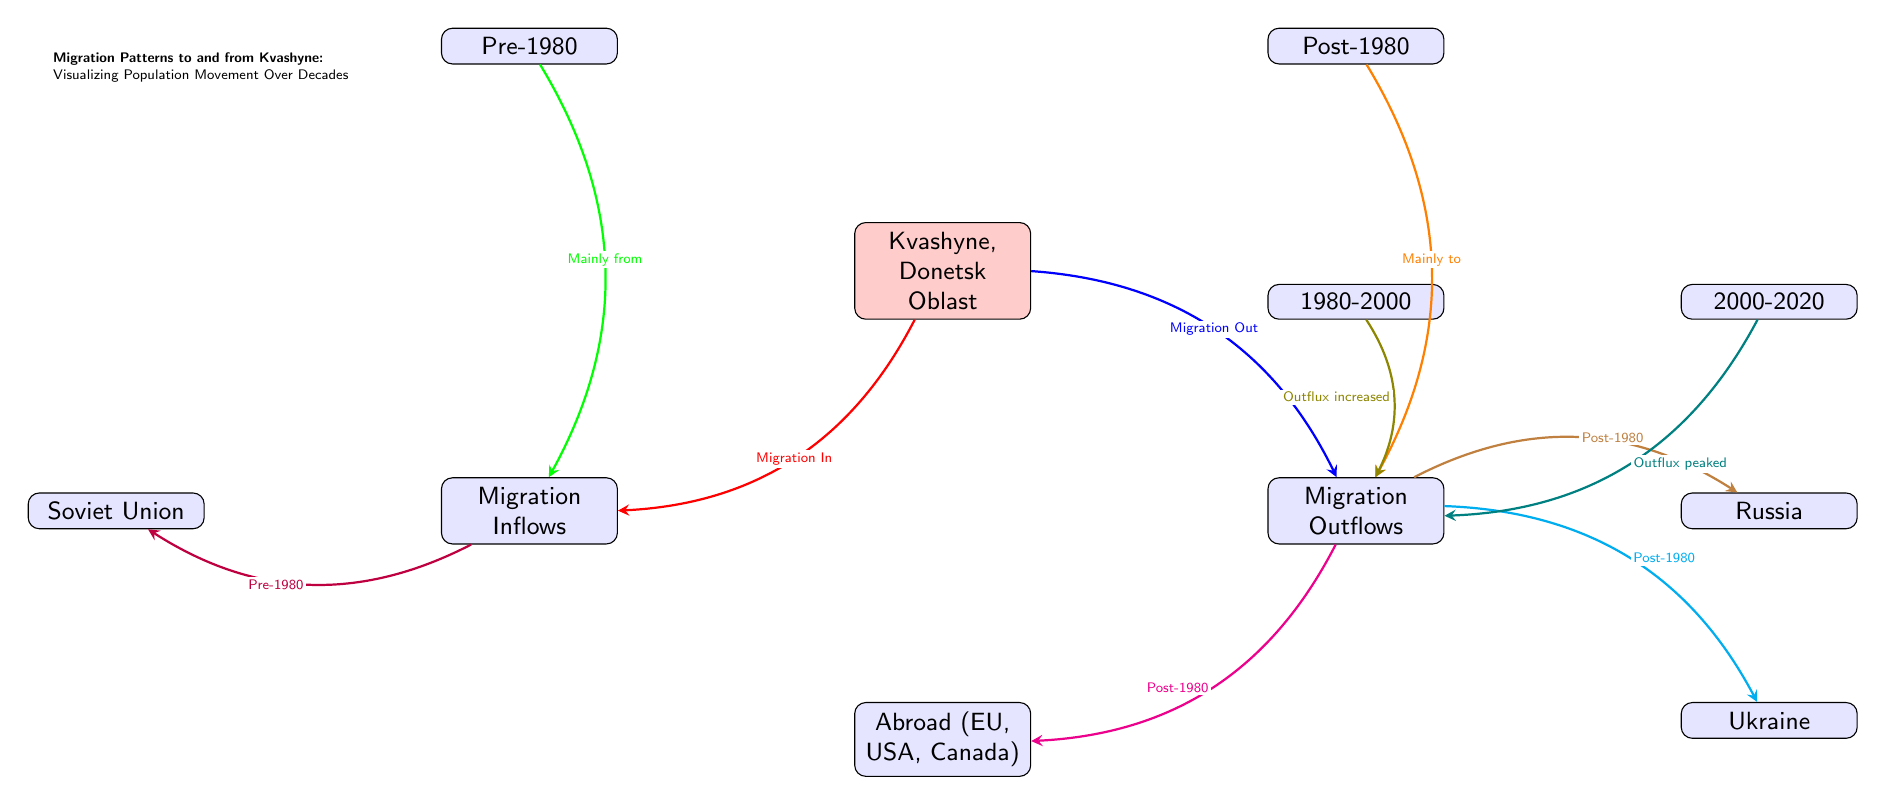What does the arrow from Kvashyne to Migration Inflows indicate? The arrow from Kvashyne to Migration Inflows signifies the flow of people moving into Kvashyne, representing the individuals migrating to the area.
Answer: Migration In What main source contributed to Migration Inflows before 1980? The diagram shows an arrow from Pre-1980 to Migration Inflows labeled “Mainly from,” indicating that the primary source of migration inflow was the Soviet Union during this period.
Answer: Soviet Union Which region experienced increased outflux in the 1980-2000 period? The arrow labeled “Outflux increased” pointing towards Migration Out from the 1980 to 2000 node indicates that this period saw an increase in the number of people leaving Kvashyne.
Answer: Outflux increased What trend is indicated for Migration Outflows between 2000 and 2020? The label “Outflux peaked” connected to Migration Outflows from the 2000-2020 node suggests that during this period, migration out of Kvashyne reached its highest point historically.
Answer: Outflux peaked Which two destinations are associated with Migration Outflows post-1980? The arrows from Migration Outflows to the nodes labeled “Russia” and “Abroad (EU, USA, Canada)” indicate that both Russia and abroad were significant destinations for people leaving Kvashyne after 1980.
Answer: Russia, Abroad (EU, USA, Canada) 